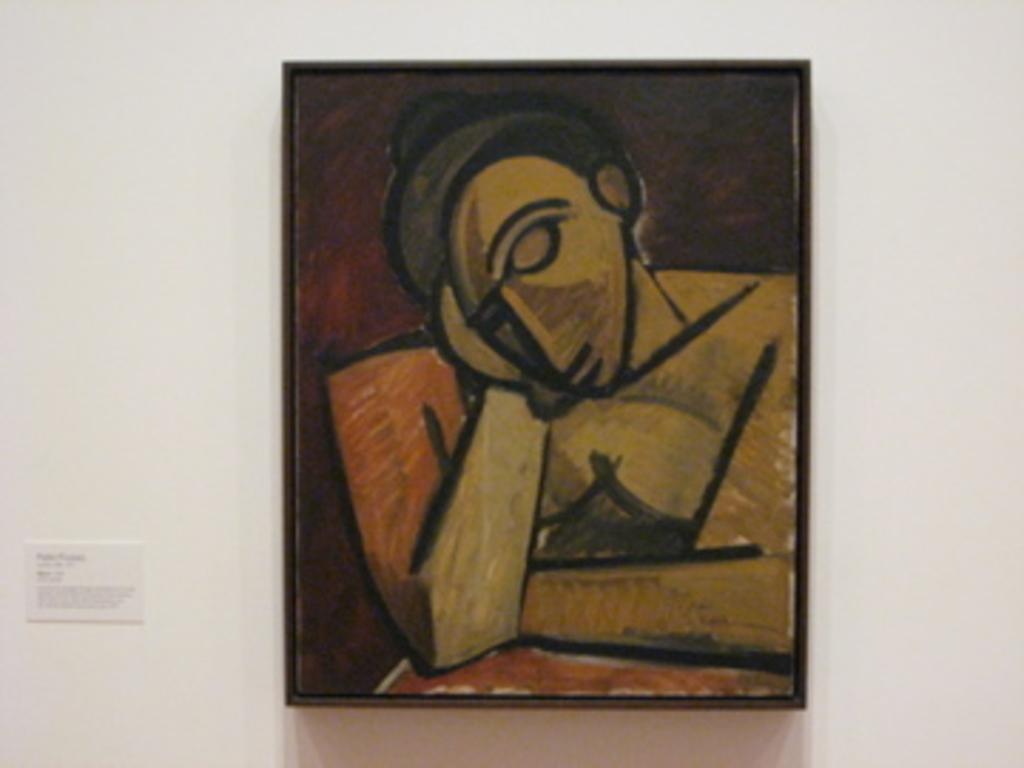Could you give a brief overview of what you see in this image? This image is taken indoors. In this image there is a wall with a picture frame on it and there is a painting in the picture frame. On the left side of the image there is a board on the wall. 